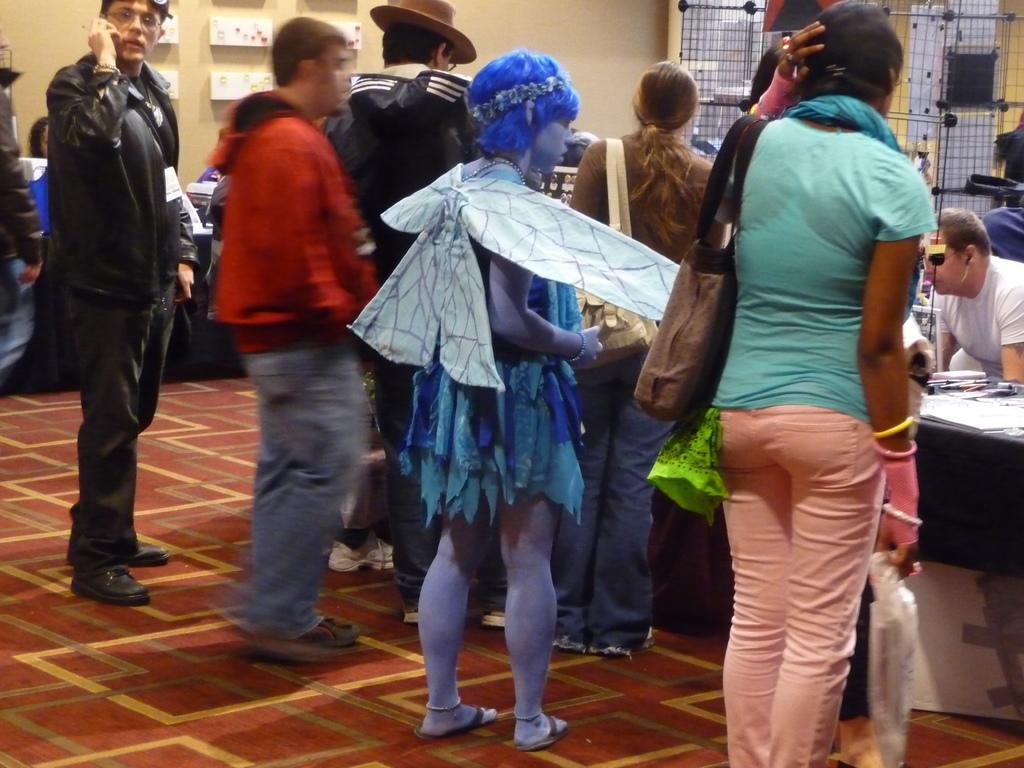Describe this image in one or two sentences. In this image we can see a girl is standing and she is wearing blue color dress, beside her one more woman is standing. She is wearing blue t-shirt with pink pant and carrying bag. Left side of the image three men are there. Behind the wall and window is present. Right side of the image one black color table is there, on table papers are there. Behind the table one man is sitting, who is wearing white color t-shirt. 